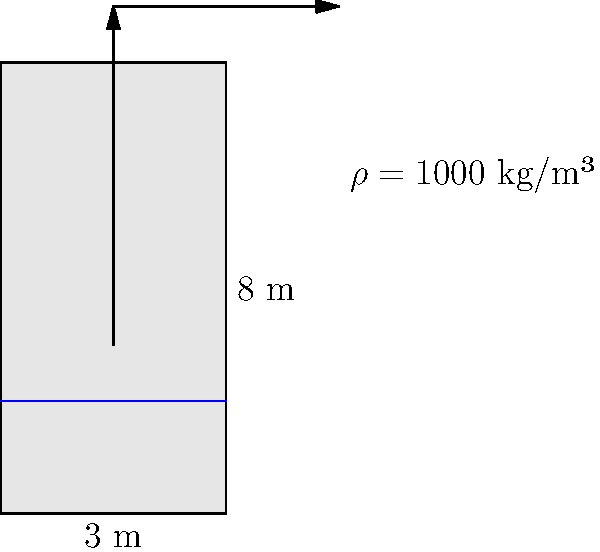A cylindrical water tank with a height of 8 meters and a radius of 3 meters is filled with water to a depth of 7 meters. Calculate the work done in pumping all the water out of the top of the tank. Assume the density of water is 1000 kg/m³ and g = 9.8 m/s². To solve this problem, we'll use the work formula for pumping water out of a tank:

$$W = \int_{0}^{h} \rho g (h-y) \pi r^2 dy$$

Where:
$W$ = work done
$\rho$ = density of water
$g$ = acceleration due to gravity
$h$ = height of water in the tank
$r$ = radius of the tank
$y$ = variable height from the bottom of the tank

Step 1: Substitute the given values:
$\rho = 1000$ kg/m³
$g = 9.8$ m/s²
$h = 7$ m (depth of water)
$r = 3$ m

Step 2: Set up the integral:
$$W = \int_{0}^{7} 1000 \cdot 9.8 \cdot (7-y) \cdot \pi \cdot 3^2 dy$$

Step 3: Simplify the constant terms:
$$W = 277146.6 \int_{0}^{7} (7-y) dy$$

Step 4: Solve the integral:
$$W = 277146.6 \left[7y - \frac{y^2}{2}\right]_{0}^{7}$$

Step 5: Evaluate the integral:
$$W = 277146.6 \left[(7 \cdot 7 - \frac{7^2}{2}) - (7 \cdot 0 - \frac{0^2}{2})\right]$$
$$W = 277146.6 \cdot (49 - 24.5)$$
$$W = 277146.6 \cdot 24.5$$
$$W = 6790091.7 \text{ J}$$

Step 6: Convert to megajoules (MJ) for a more manageable number:
$$W = 6.79 \text{ MJ}$$
Answer: 6.79 MJ 